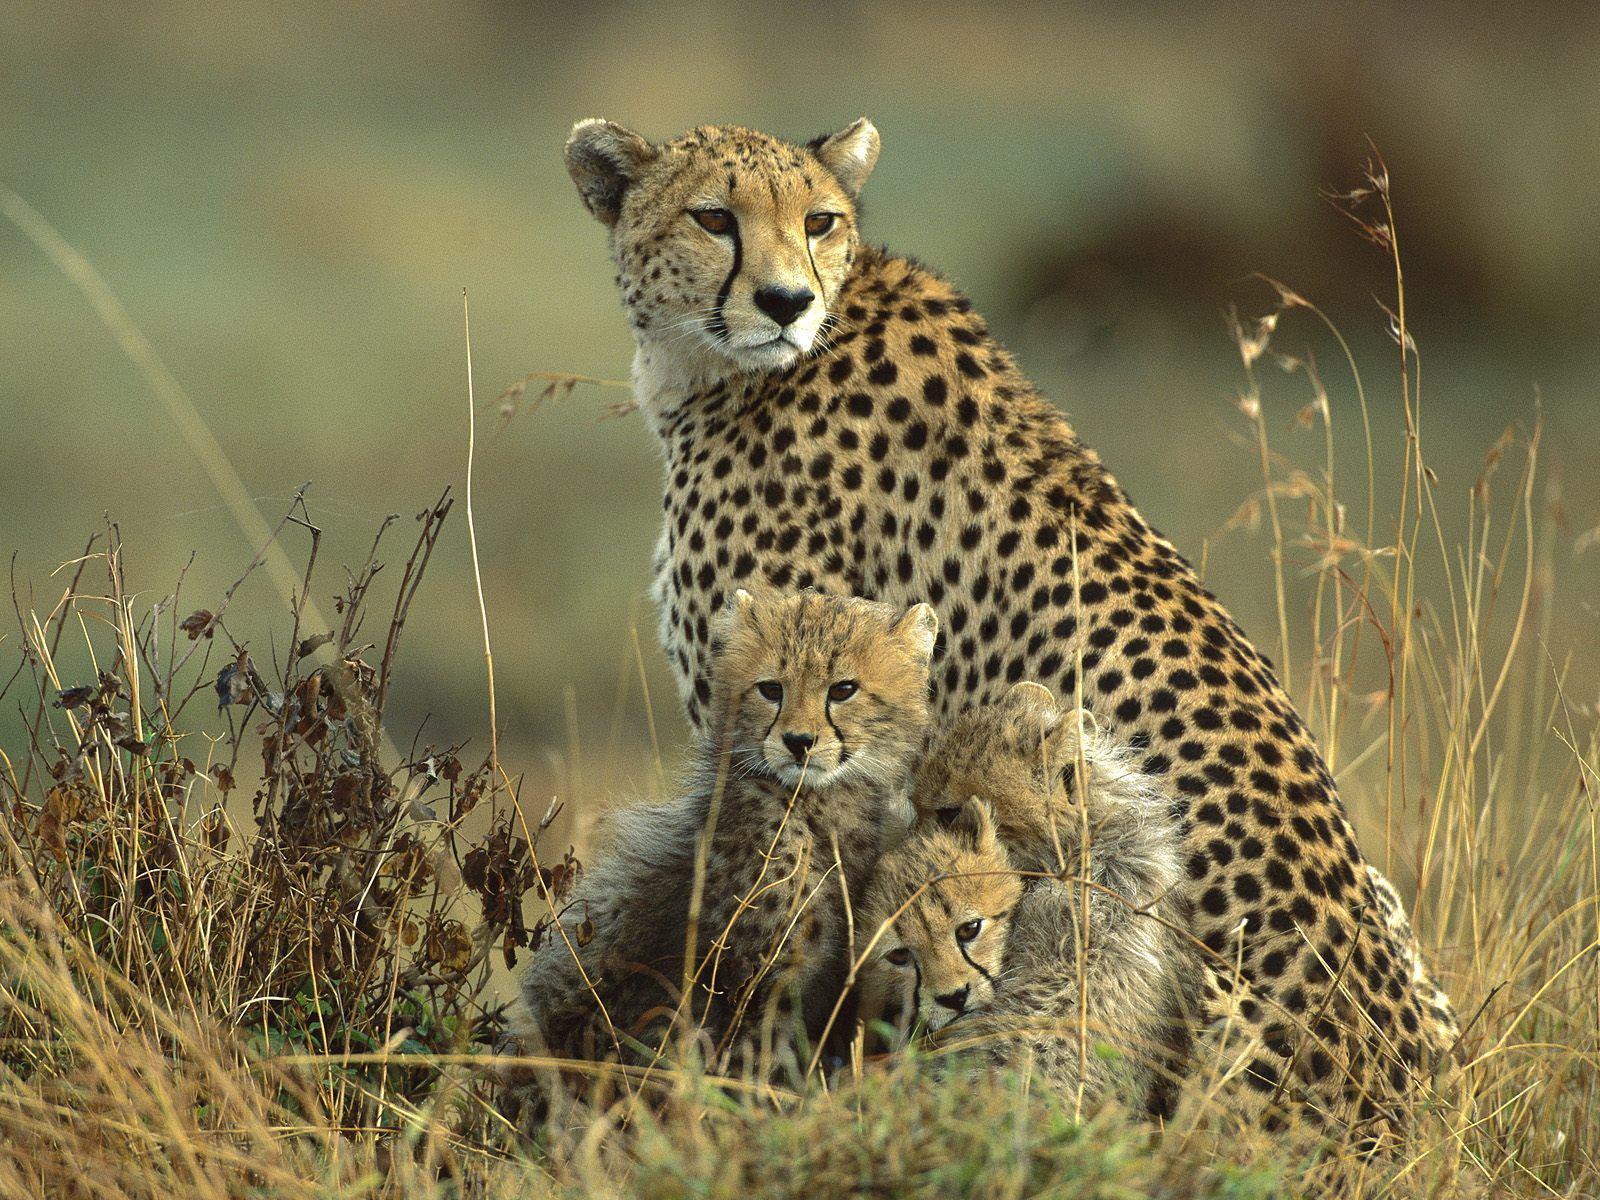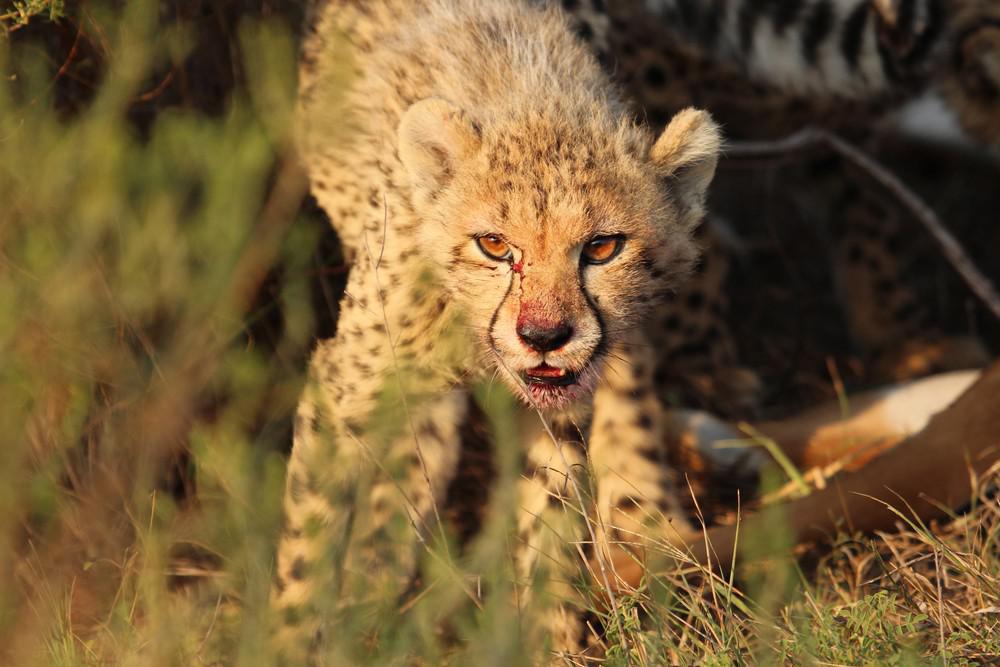The first image is the image on the left, the second image is the image on the right. Analyze the images presented: Is the assertion "The picture on the left shows at least two baby cheetah sitting down next to their mother." valid? Answer yes or no. Yes. 